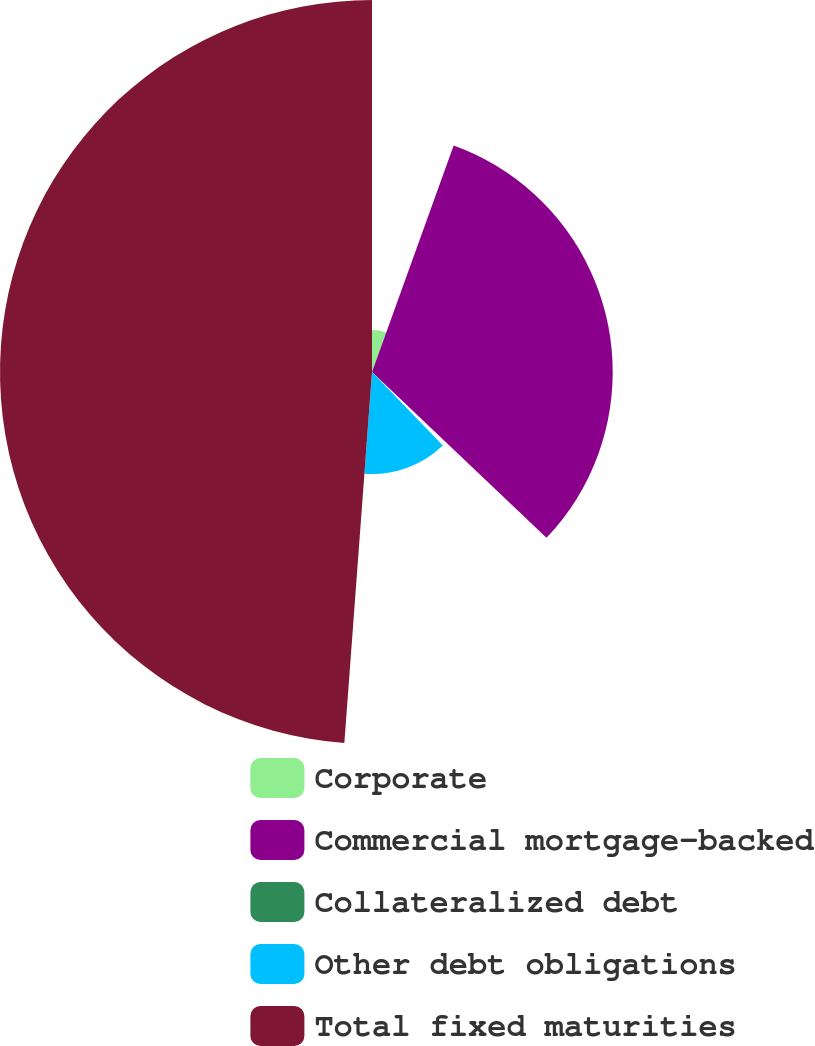<chart> <loc_0><loc_0><loc_500><loc_500><pie_chart><fcel>Corporate<fcel>Commercial mortgage-backed<fcel>Collateralized debt<fcel>Other debt obligations<fcel>Total fixed maturities<nl><fcel>5.51%<fcel>31.59%<fcel>0.7%<fcel>13.39%<fcel>48.82%<nl></chart> 